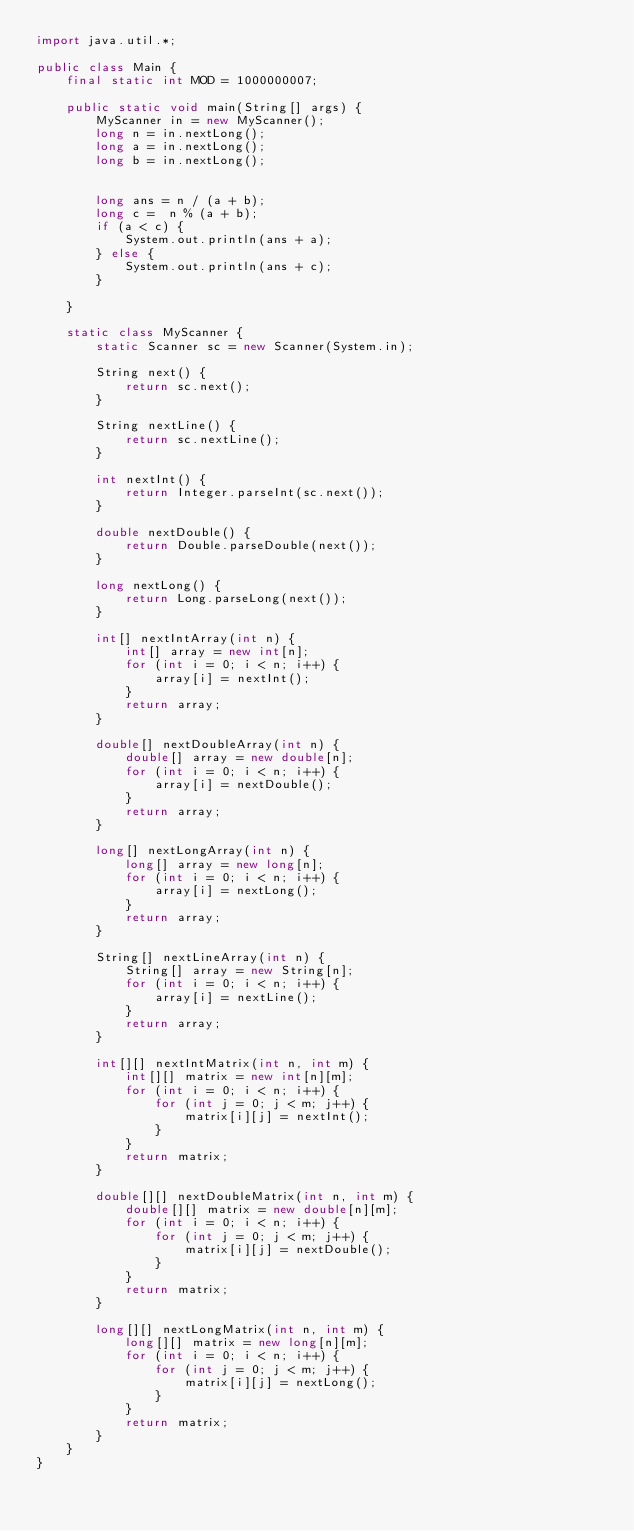<code> <loc_0><loc_0><loc_500><loc_500><_Java_>import java.util.*;

public class Main {
    final static int MOD = 1000000007;
    
    public static void main(String[] args) {
        MyScanner in = new MyScanner();
        long n = in.nextLong();
        long a = in.nextLong();
        long b = in.nextLong();
        

        long ans = n / (a + b);
        long c =  n % (a + b);
        if (a < c) {
            System.out.println(ans + a);
        } else {
            System.out.println(ans + c);
        }
        
    }
    
    static class MyScanner {
        static Scanner sc = new Scanner(System.in);
        
        String next() {
            return sc.next();
        }
        
        String nextLine() {
            return sc.nextLine();
        }
        
        int nextInt() {
            return Integer.parseInt(sc.next());
        }
        
        double nextDouble() {
            return Double.parseDouble(next());
        }
        
        long nextLong() {
            return Long.parseLong(next());
        }
        
        int[] nextIntArray(int n) {
            int[] array = new int[n];
            for (int i = 0; i < n; i++) {
                array[i] = nextInt();
            }
            return array;
        }
        
        double[] nextDoubleArray(int n) {
            double[] array = new double[n];
            for (int i = 0; i < n; i++) {
                array[i] = nextDouble();
            }
            return array;
        }
        
        long[] nextLongArray(int n) {
            long[] array = new long[n];
            for (int i = 0; i < n; i++) {
                array[i] = nextLong();
            }
            return array;
        }
        
        String[] nextLineArray(int n) {
            String[] array = new String[n];
            for (int i = 0; i < n; i++) {
                array[i] = nextLine();
            }
            return array;
        }
        
        int[][] nextIntMatrix(int n, int m) {
            int[][] matrix = new int[n][m];
            for (int i = 0; i < n; i++) {
                for (int j = 0; j < m; j++) {
                    matrix[i][j] = nextInt();
                }
            }
            return matrix;
        }
        
        double[][] nextDoubleMatrix(int n, int m) {
            double[][] matrix = new double[n][m];
            for (int i = 0; i < n; i++) {
                for (int j = 0; j < m; j++) {
                    matrix[i][j] = nextDouble();
                }
            }
            return matrix;
        }
        
        long[][] nextLongMatrix(int n, int m) {
            long[][] matrix = new long[n][m];
            for (int i = 0; i < n; i++) {
                for (int j = 0; j < m; j++) {
                    matrix[i][j] = nextLong();
                }
            }
            return matrix;
        }
    }
}</code> 